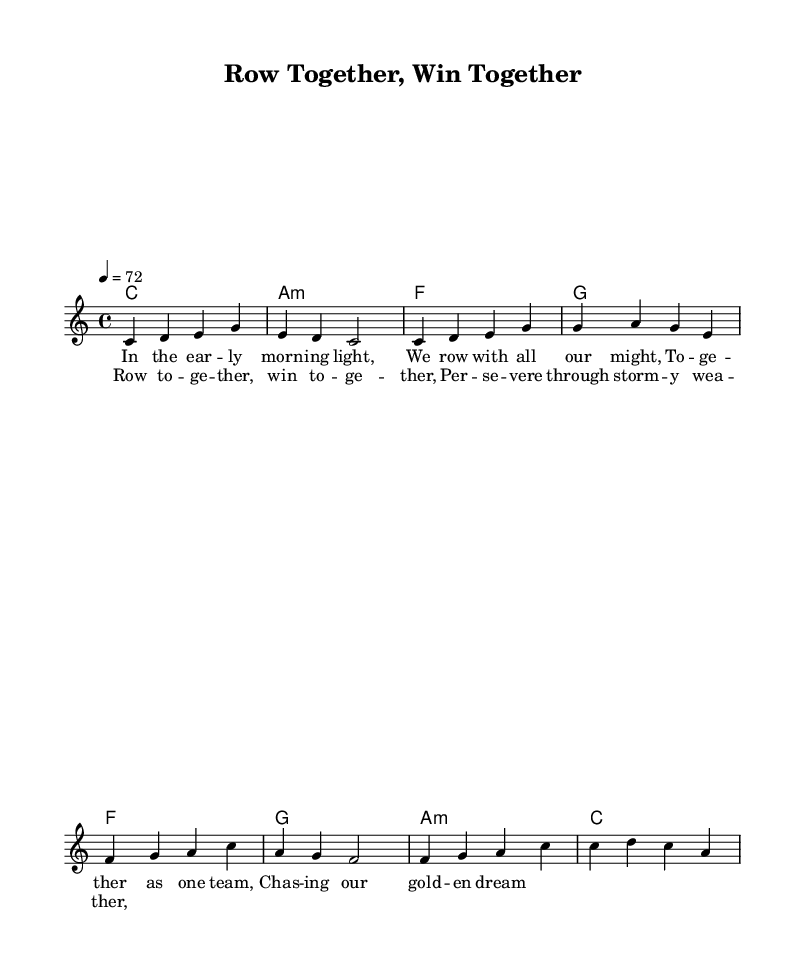What is the key signature of this music? The key signature is C major, which has no sharps or flats.
Answer: C major What is the time signature of this piece? The time signature, indicated at the beginning of the music, is 4/4, meaning there are four beats per measure.
Answer: 4/4 What is the tempo marking? The tempo marking indicates that the piece should be played at a speed of 72 beats per minute.
Answer: 72 How many measures are in the verse section? By counting the measures in the melody section labeled as Verse, there are 4 measures.
Answer: 4 What is the first lyric line of the chorus? The first lyric line of the chorus, as indicated in the sheet music, is "Row together, win together."
Answer: Row together, win together Which harmony chord follows the first measure of the chorus? The first measure of the chorus is followed by an F major chord (F), as shown in the harmonies section.
Answer: F What is the overall theme of the lyrics in the song? The overall theme of the lyrics focuses on teamwork and perseverance in the face of challenges, as reflected in the lyrics emphasizing togetherness.
Answer: Teamwork and perseverance 